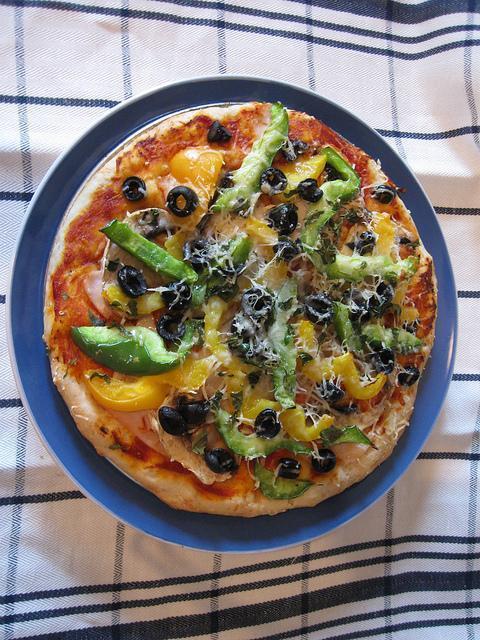How many wheels of the skateboard are touching the ground?
Give a very brief answer. 0. 